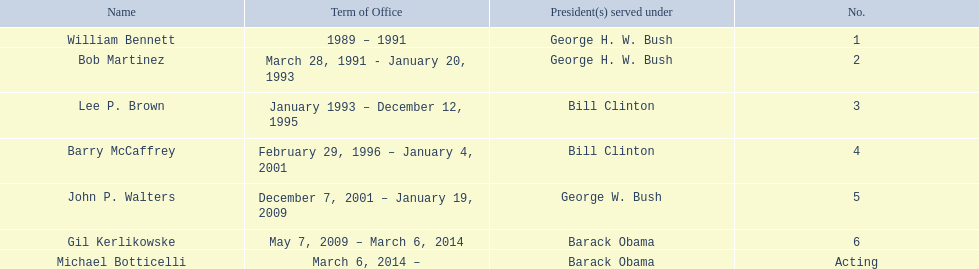Who served during barack obama's presidency? Gil Kerlikowske. 